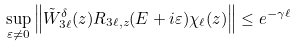Convert formula to latex. <formula><loc_0><loc_0><loc_500><loc_500>\sup _ { \varepsilon \ne 0 } \left \| { \tilde { W } } _ { 3 \ell } ^ { \delta } ( { z } ) R _ { 3 \ell , { z } } ( E + i \varepsilon ) \chi _ { \ell } ( { z } ) \right \| \leq e ^ { - \gamma \ell }</formula> 